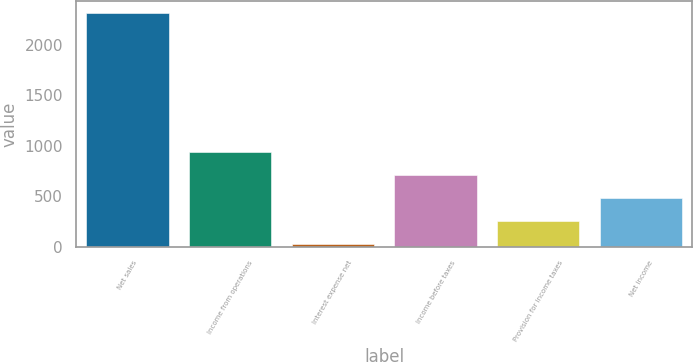Convert chart. <chart><loc_0><loc_0><loc_500><loc_500><bar_chart><fcel>Net sales<fcel>Income from operations<fcel>Interest expense net<fcel>Income before taxes<fcel>Provision for income taxes<fcel>Net income<nl><fcel>2316<fcel>941.76<fcel>25.6<fcel>712.72<fcel>254.64<fcel>483.68<nl></chart> 